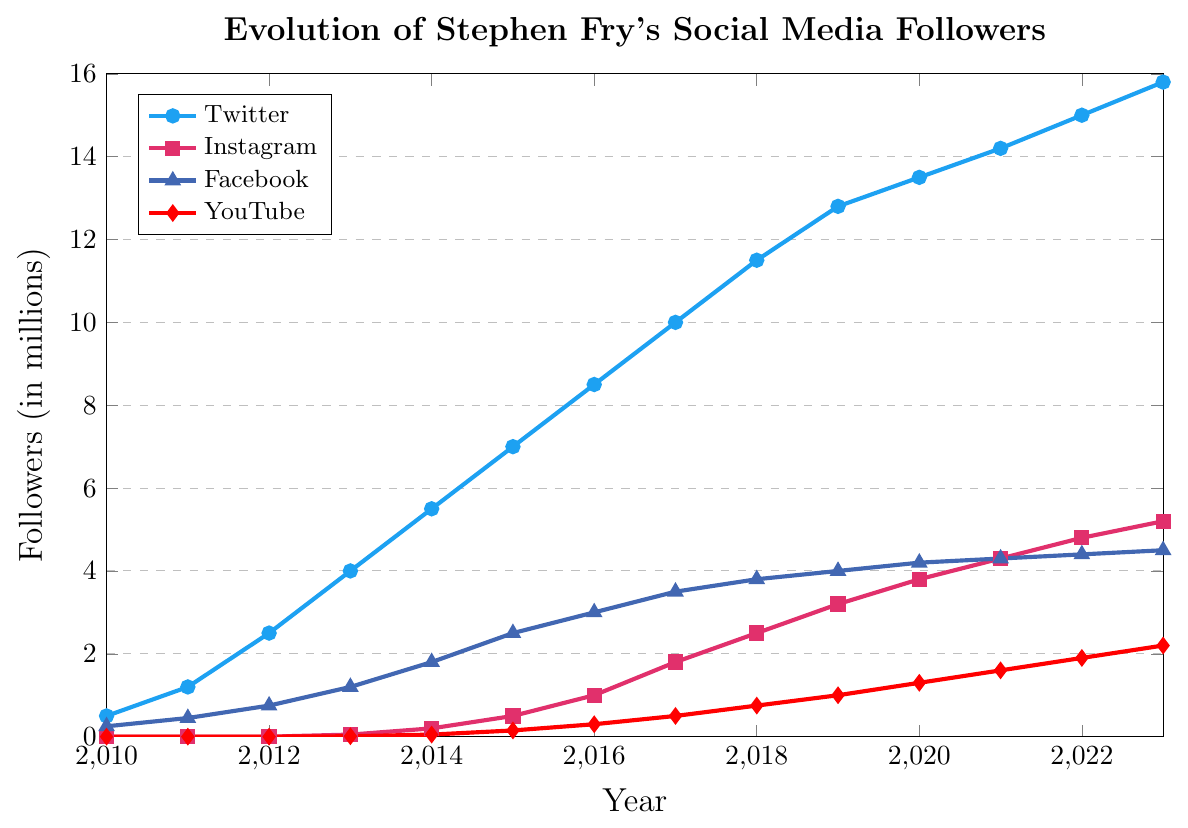What year did Stephen Fry's YouTube follower count first reach 1 million? According to the chart, Stephen Fry's YouTube follower count reached 1 million in 2019. This can be seen where the YouTube line (red with diamond marks) crosses the 1 million mark.
Answer: 2019 In which year did Stephen Fry's Instagram follower count exceed his Facebook follower count? Stephen Fry's Instagram follower count (pink line with square marks) first exceeds his Facebook follower count (blue line with triangle marks) in 2019. Before 2019, Facebook followers were higher. From 2019 onwards, Instagram followers are higher.
Answer: 2019 Between which years did Stephen Fry's Twitter follower count see the largest increase? The largest increase in Twitter follower count (blue line with circle marks) can be observed between 2012 and 2013, where the count rose from 2.5 million to 4 million, an increase of 1.5 million.
Answer: 2012-2013 What was the difference in Stephen Fry's Twitter followers between 2016 and 2012? In 2016, Stephen Fry had 8.5 million Twitter followers, and in 2012, he had 2.5 million followers. The difference is 8.5 million - 2.5 million = 6 million.
Answer: 6 million Which social media platform saw the fastest growth rate in followers from 2015 to 2016? From 2015 to 2016, YouTube saw the fastest growth rate in followers, rising from 0.15 million to 0.3 million, which is a 100% increase (doubled). Twitter increased by 1.5 million (21.4%), Instagram by 0.5 million (100%), and Facebook by 0.5 million (20%).
Answer: YouTube By how many followers did Stephen Fry's Instagram count grow between 2018 and 2020? In 2018, Stephen Fry had 2.5 million Instagram followers, and in 2020, he had 3.8 million. The growth is 3.8 million - 2.5 million = 1.3 million.
Answer: 1.3 million What is the average number of Facebook followers between 2010 and 2023? Sum of Facebook followers from 2010 to 2023: 0.25 + 0.45 + 0.75 + 1.2 + 1.8 + 2.5 + 3 + 3.5 + 3.8 + 4 + 4.2 + 4.3 + 4.4 + 4.5 = 38.45 million. Divide by 14 years: 38.45 / 14 ≈ 2.75 million.
Answer: 2.75 million What was the total increase in Stephen Fry's social media followers across all platforms from 2020 to 2023? Twitter: 15.8M - 13.5M = 2.3M, Instagram: 5.2M - 3.8M = 1.4M, Facebook: 4.5M - 4.2M = 0.3M, YouTube: 2.2M - 1.3M = 0.9M. Total increase = 2.3M + 1.4M + 0.3M + 0.9M = 4.9M.
Answer: 4.9 million How many more followers did Stephen Fry have on Twitter compared to Instagram in 2023? In 2023, Stephen Fry had 15.8 million Twitter followers and 5.2 million Instagram followers. The difference is 15.8 million - 5.2 million = 10.6 million.
Answer: 10.6 million Which platform had the least number of followers in 2015, and what was the count? In 2015, YouTube had the least number of followers, which was 0.15 million.
Answer: YouTube, 0.15 million 